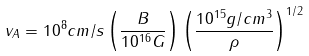<formula> <loc_0><loc_0><loc_500><loc_500>v _ { A } = 1 0 ^ { 8 } c m / s \left ( \frac { B } { 1 0 ^ { 1 6 } G } \right ) \left ( \frac { 1 0 ^ { 1 5 } g / c m ^ { 3 } } { \rho } \right ) ^ { 1 / 2 }</formula> 